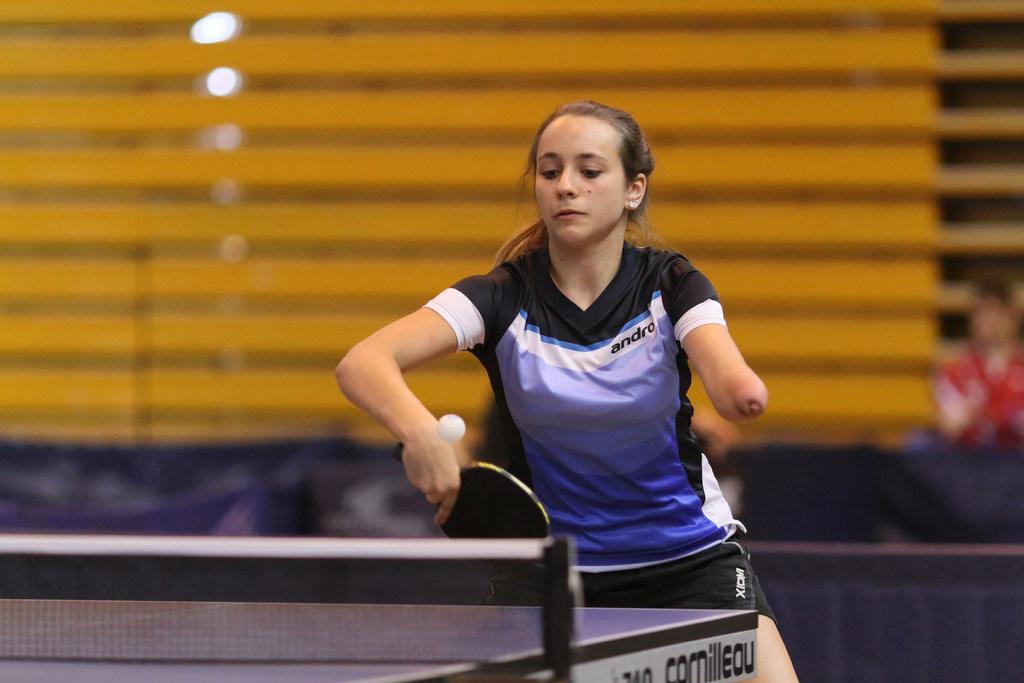How would you summarize this image in a sentence or two? In this picture there is a woman holding a bat and a ball. There is a tennis table and a light at the background. 